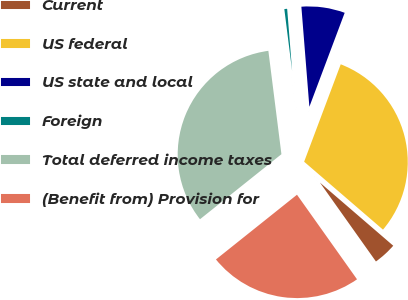<chart> <loc_0><loc_0><loc_500><loc_500><pie_chart><fcel>Current<fcel>US federal<fcel>US state and local<fcel>Foreign<fcel>Total deferred income taxes<fcel>(Benefit from) Provision for<nl><fcel>3.86%<fcel>30.6%<fcel>6.99%<fcel>0.73%<fcel>33.73%<fcel>24.1%<nl></chart> 